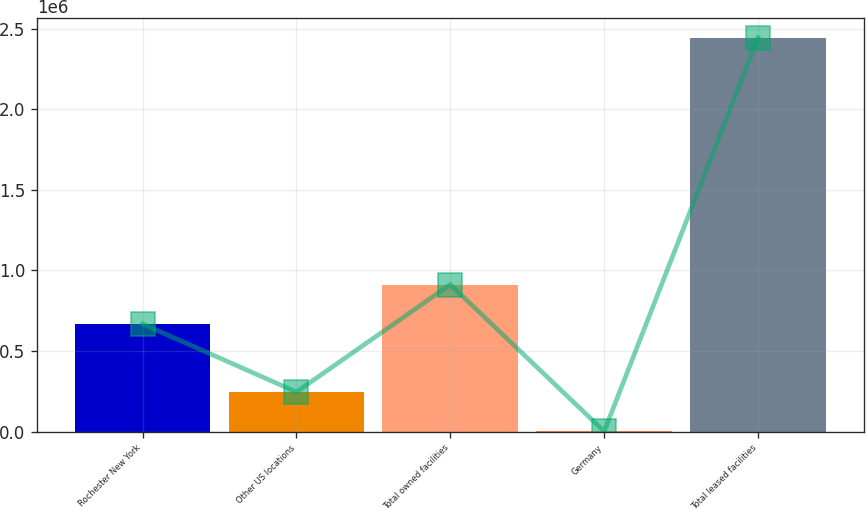Convert chart to OTSL. <chart><loc_0><loc_0><loc_500><loc_500><bar_chart><fcel>Rochester New York<fcel>Other US locations<fcel>Total owned facilities<fcel>Germany<fcel>Total leased facilities<nl><fcel>668000<fcel>245500<fcel>912300<fcel>1200<fcel>2.4442e+06<nl></chart> 